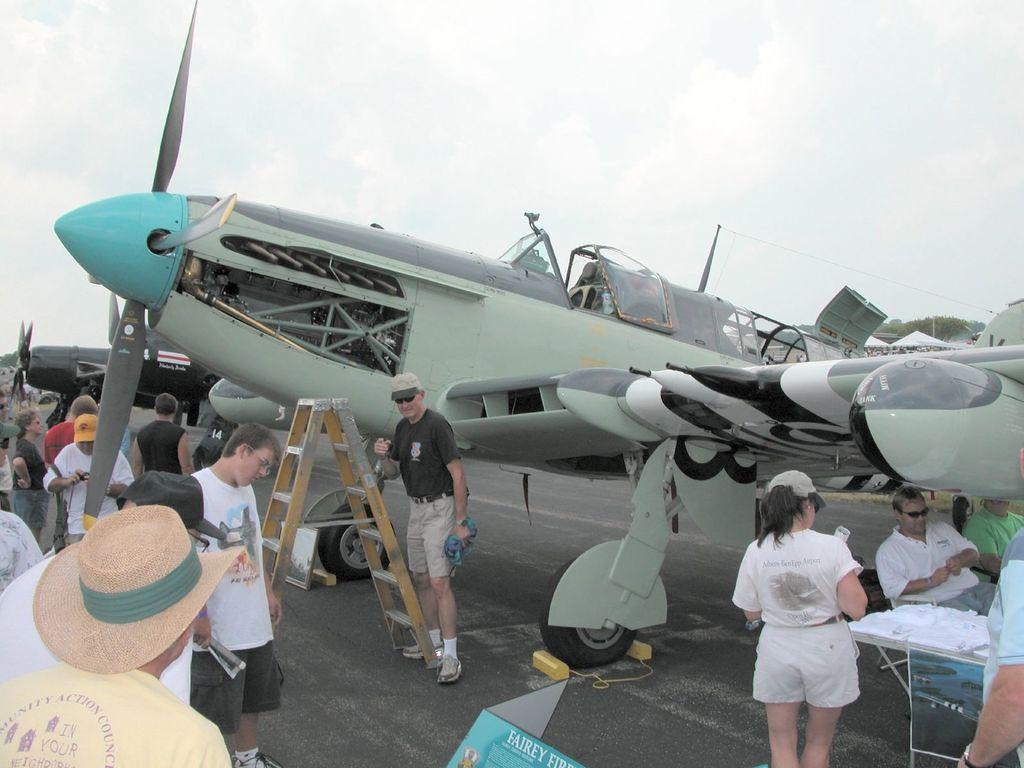How would you summarize this image in a sentence or two? In this image I see an aircraft, a ladder, few people over here and a table. In the background I see another aircraft and the sky. 